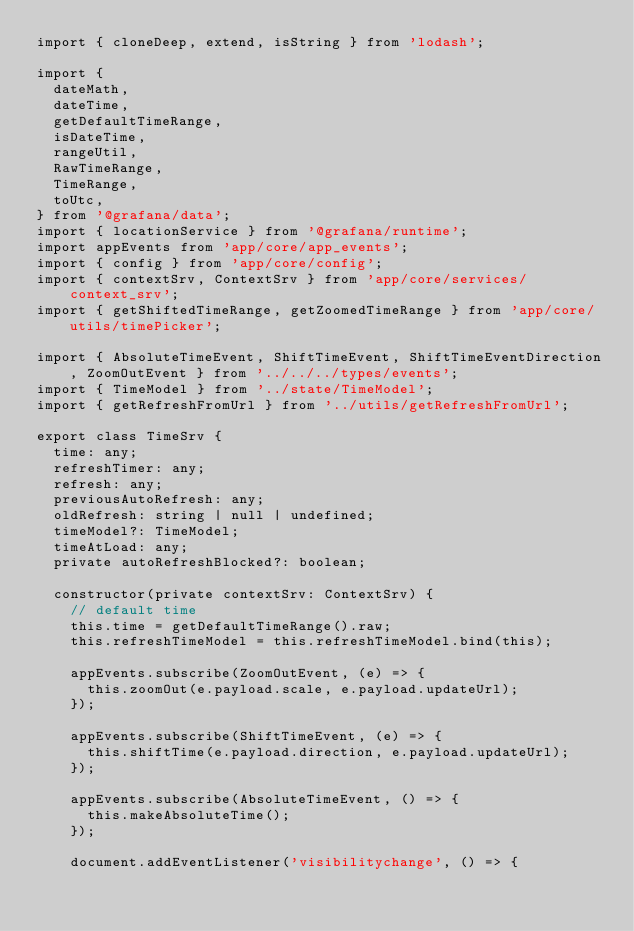<code> <loc_0><loc_0><loc_500><loc_500><_TypeScript_>import { cloneDeep, extend, isString } from 'lodash';

import {
  dateMath,
  dateTime,
  getDefaultTimeRange,
  isDateTime,
  rangeUtil,
  RawTimeRange,
  TimeRange,
  toUtc,
} from '@grafana/data';
import { locationService } from '@grafana/runtime';
import appEvents from 'app/core/app_events';
import { config } from 'app/core/config';
import { contextSrv, ContextSrv } from 'app/core/services/context_srv';
import { getShiftedTimeRange, getZoomedTimeRange } from 'app/core/utils/timePicker';

import { AbsoluteTimeEvent, ShiftTimeEvent, ShiftTimeEventDirection, ZoomOutEvent } from '../../../types/events';
import { TimeModel } from '../state/TimeModel';
import { getRefreshFromUrl } from '../utils/getRefreshFromUrl';

export class TimeSrv {
  time: any;
  refreshTimer: any;
  refresh: any;
  previousAutoRefresh: any;
  oldRefresh: string | null | undefined;
  timeModel?: TimeModel;
  timeAtLoad: any;
  private autoRefreshBlocked?: boolean;

  constructor(private contextSrv: ContextSrv) {
    // default time
    this.time = getDefaultTimeRange().raw;
    this.refreshTimeModel = this.refreshTimeModel.bind(this);

    appEvents.subscribe(ZoomOutEvent, (e) => {
      this.zoomOut(e.payload.scale, e.payload.updateUrl);
    });

    appEvents.subscribe(ShiftTimeEvent, (e) => {
      this.shiftTime(e.payload.direction, e.payload.updateUrl);
    });

    appEvents.subscribe(AbsoluteTimeEvent, () => {
      this.makeAbsoluteTime();
    });

    document.addEventListener('visibilitychange', () => {</code> 